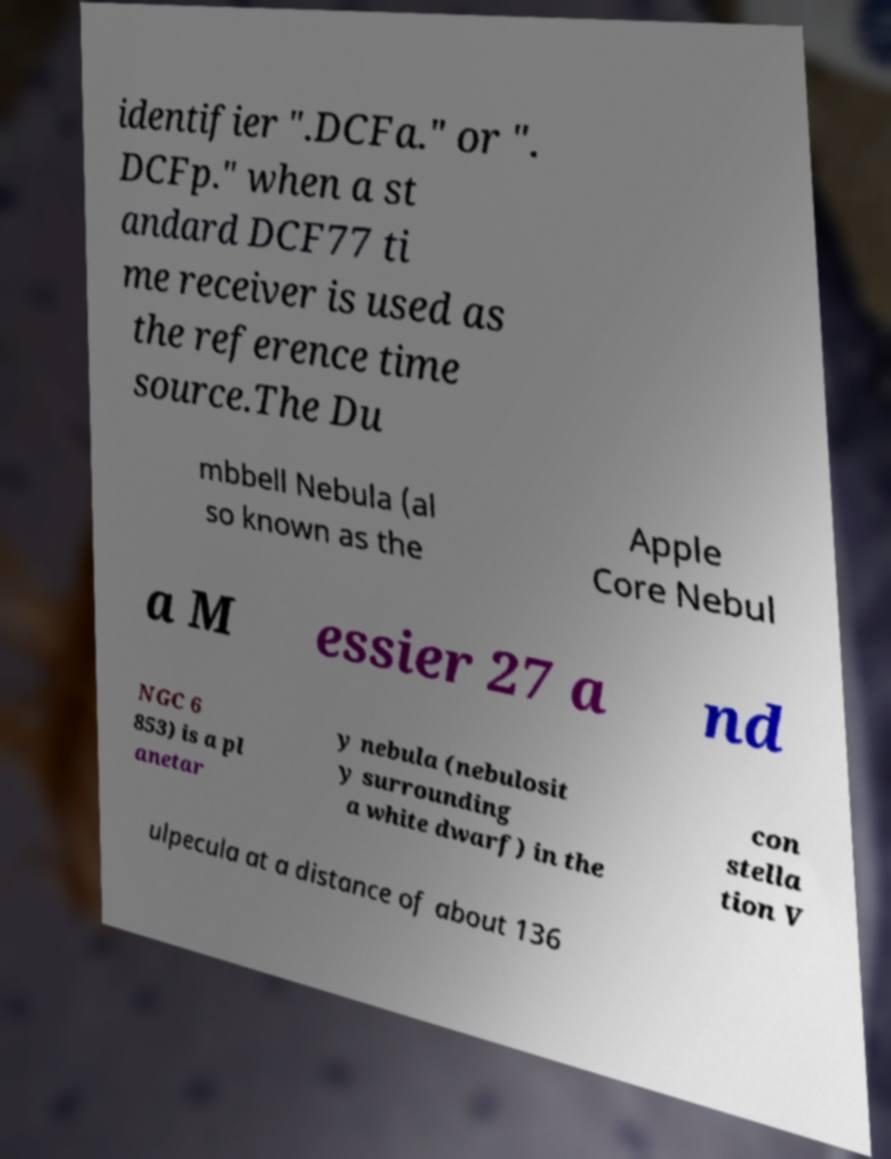What messages or text are displayed in this image? I need them in a readable, typed format. identifier ".DCFa." or ". DCFp." when a st andard DCF77 ti me receiver is used as the reference time source.The Du mbbell Nebula (al so known as the Apple Core Nebul a M essier 27 a nd NGC 6 853) is a pl anetar y nebula (nebulosit y surrounding a white dwarf) in the con stella tion V ulpecula at a distance of about 136 